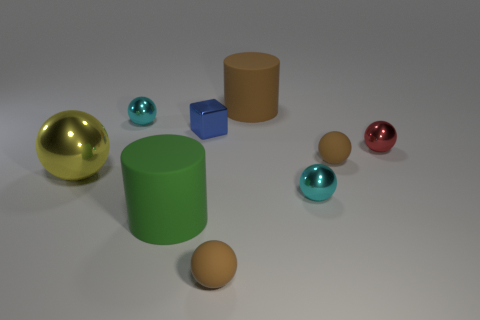Subtract all cyan shiny balls. How many balls are left? 4 Subtract 3 balls. How many balls are left? 3 Add 1 tiny brown objects. How many objects exist? 10 Subtract all yellow spheres. How many spheres are left? 5 Subtract all rubber cylinders. Subtract all brown objects. How many objects are left? 4 Add 7 small red shiny balls. How many small red shiny balls are left? 8 Add 3 gray rubber cylinders. How many gray rubber cylinders exist? 3 Subtract 0 cyan cylinders. How many objects are left? 9 Subtract all balls. How many objects are left? 3 Subtract all brown spheres. Subtract all gray blocks. How many spheres are left? 4 